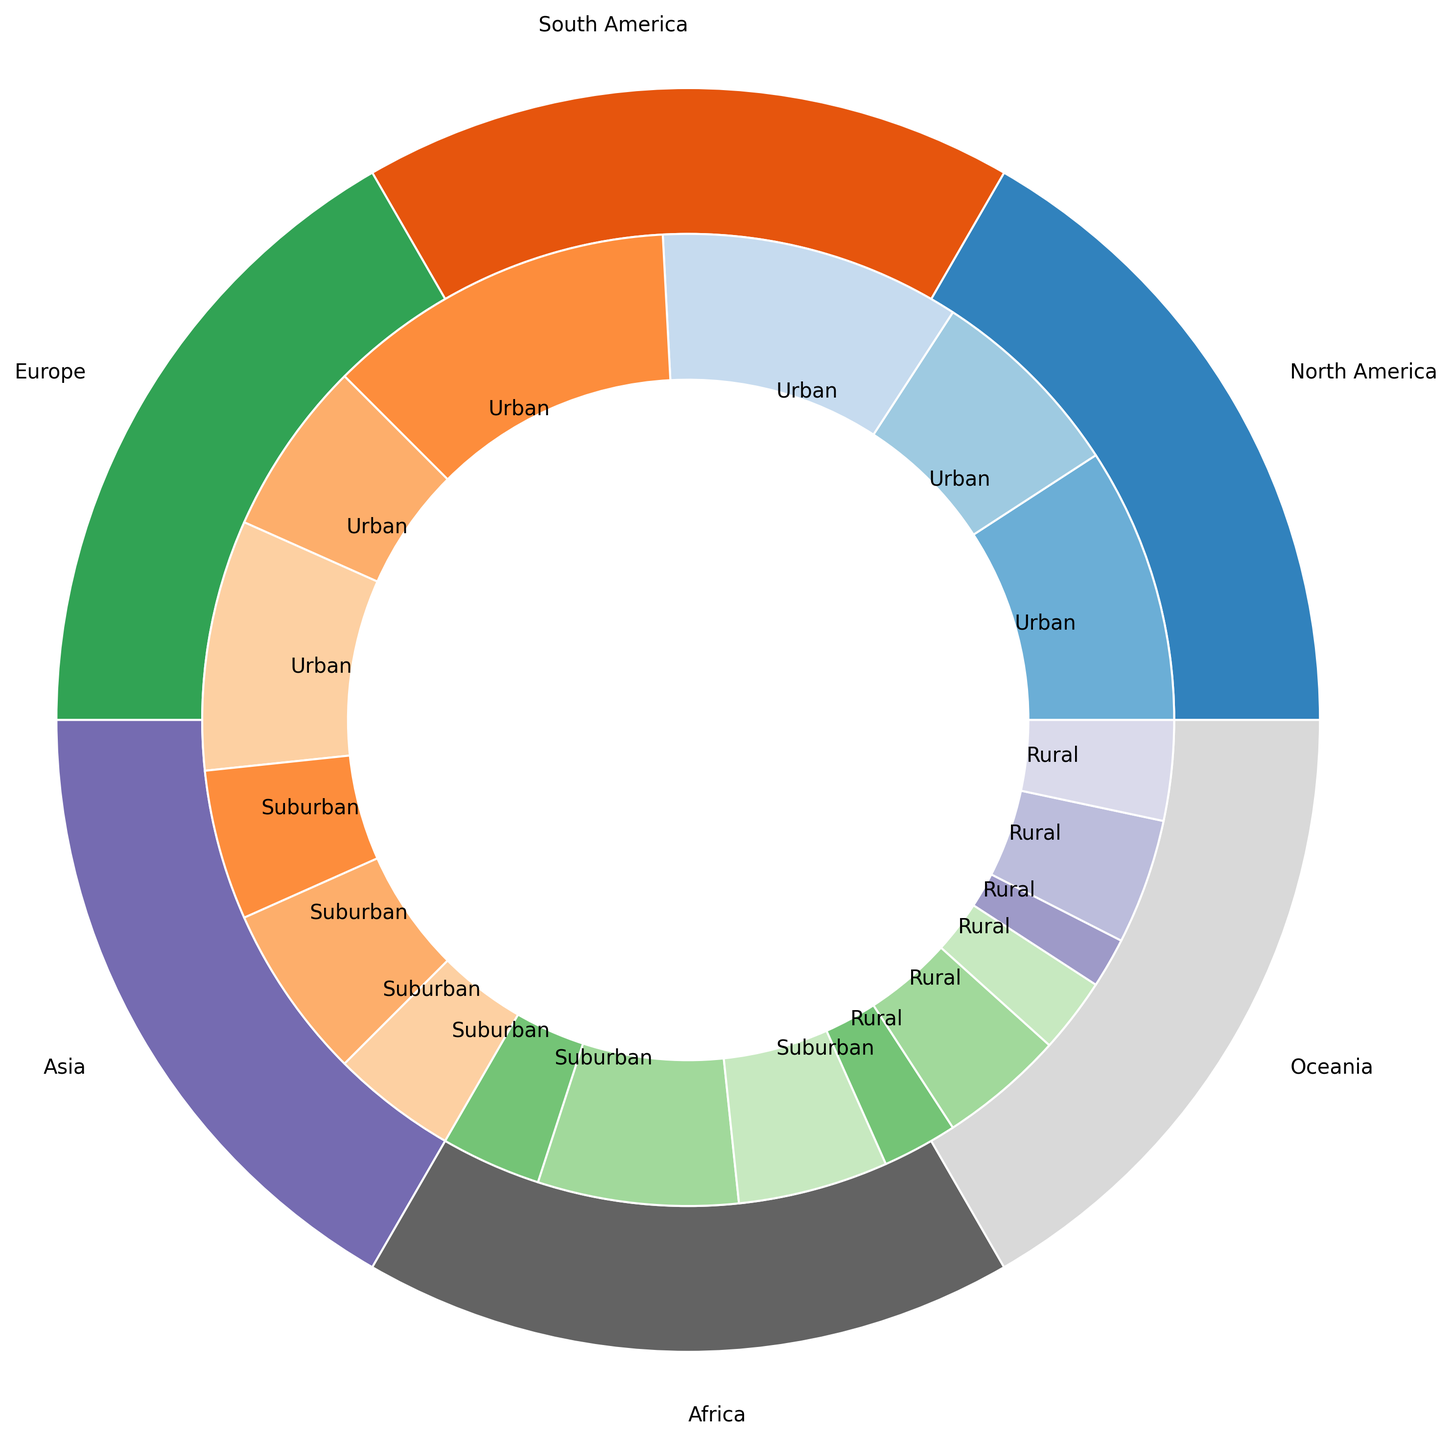What is the percentage contribution of urban transport in Europe to its regional total? First, identify the urban value for Europe, which is 60. Then, find the total of all transportation types in Europe (60 + 25 + 15 = 100). Finally, calculate the percentage as (60 / 100) * 100%.
Answer: 60% Which region has the highest proportion of suburban transport? Observe the inner pie slices labeled "Suburban" and compare their sizes across all regions. South America and Africa each have a high proportion of 40%, but since Africa has a slightly larger slice visually, it is the highest.
Answer: Africa What is the total percentage of rural transport combined across all regions? Sum up all the rural transport values from each region (15 + 25 + 15 + 10 + 25 + 20 = 110). Then, calculate the overall total from the outer ring portions (total = 55 + 30 + 15 + 40 + 35 + 25 + 60 + 25 + 15 + 70 + 20 + 10 + 35 + 40 + 25 + 50 + 30 + 20 = 600). Finally, find the percentage as (110 / 600) * 100%.
Answer: 18.33% Is the proportion of urban transport in Asia greater than the combined suburban and rural transports in North America? First, determine the proportion of urban transport in Asia, which is 70%. Next, add the suburban and rural transport values in North America (30 + 15 = 45). Clearly, 70% > 45%.
Answer: Yes Which region has the smallest proportion of rural transport? Examine the inner pie slices marked "Rural" and compare their sizes among the regions. Asia's rural transport segment is the smallest at 10%.
Answer: Asia 